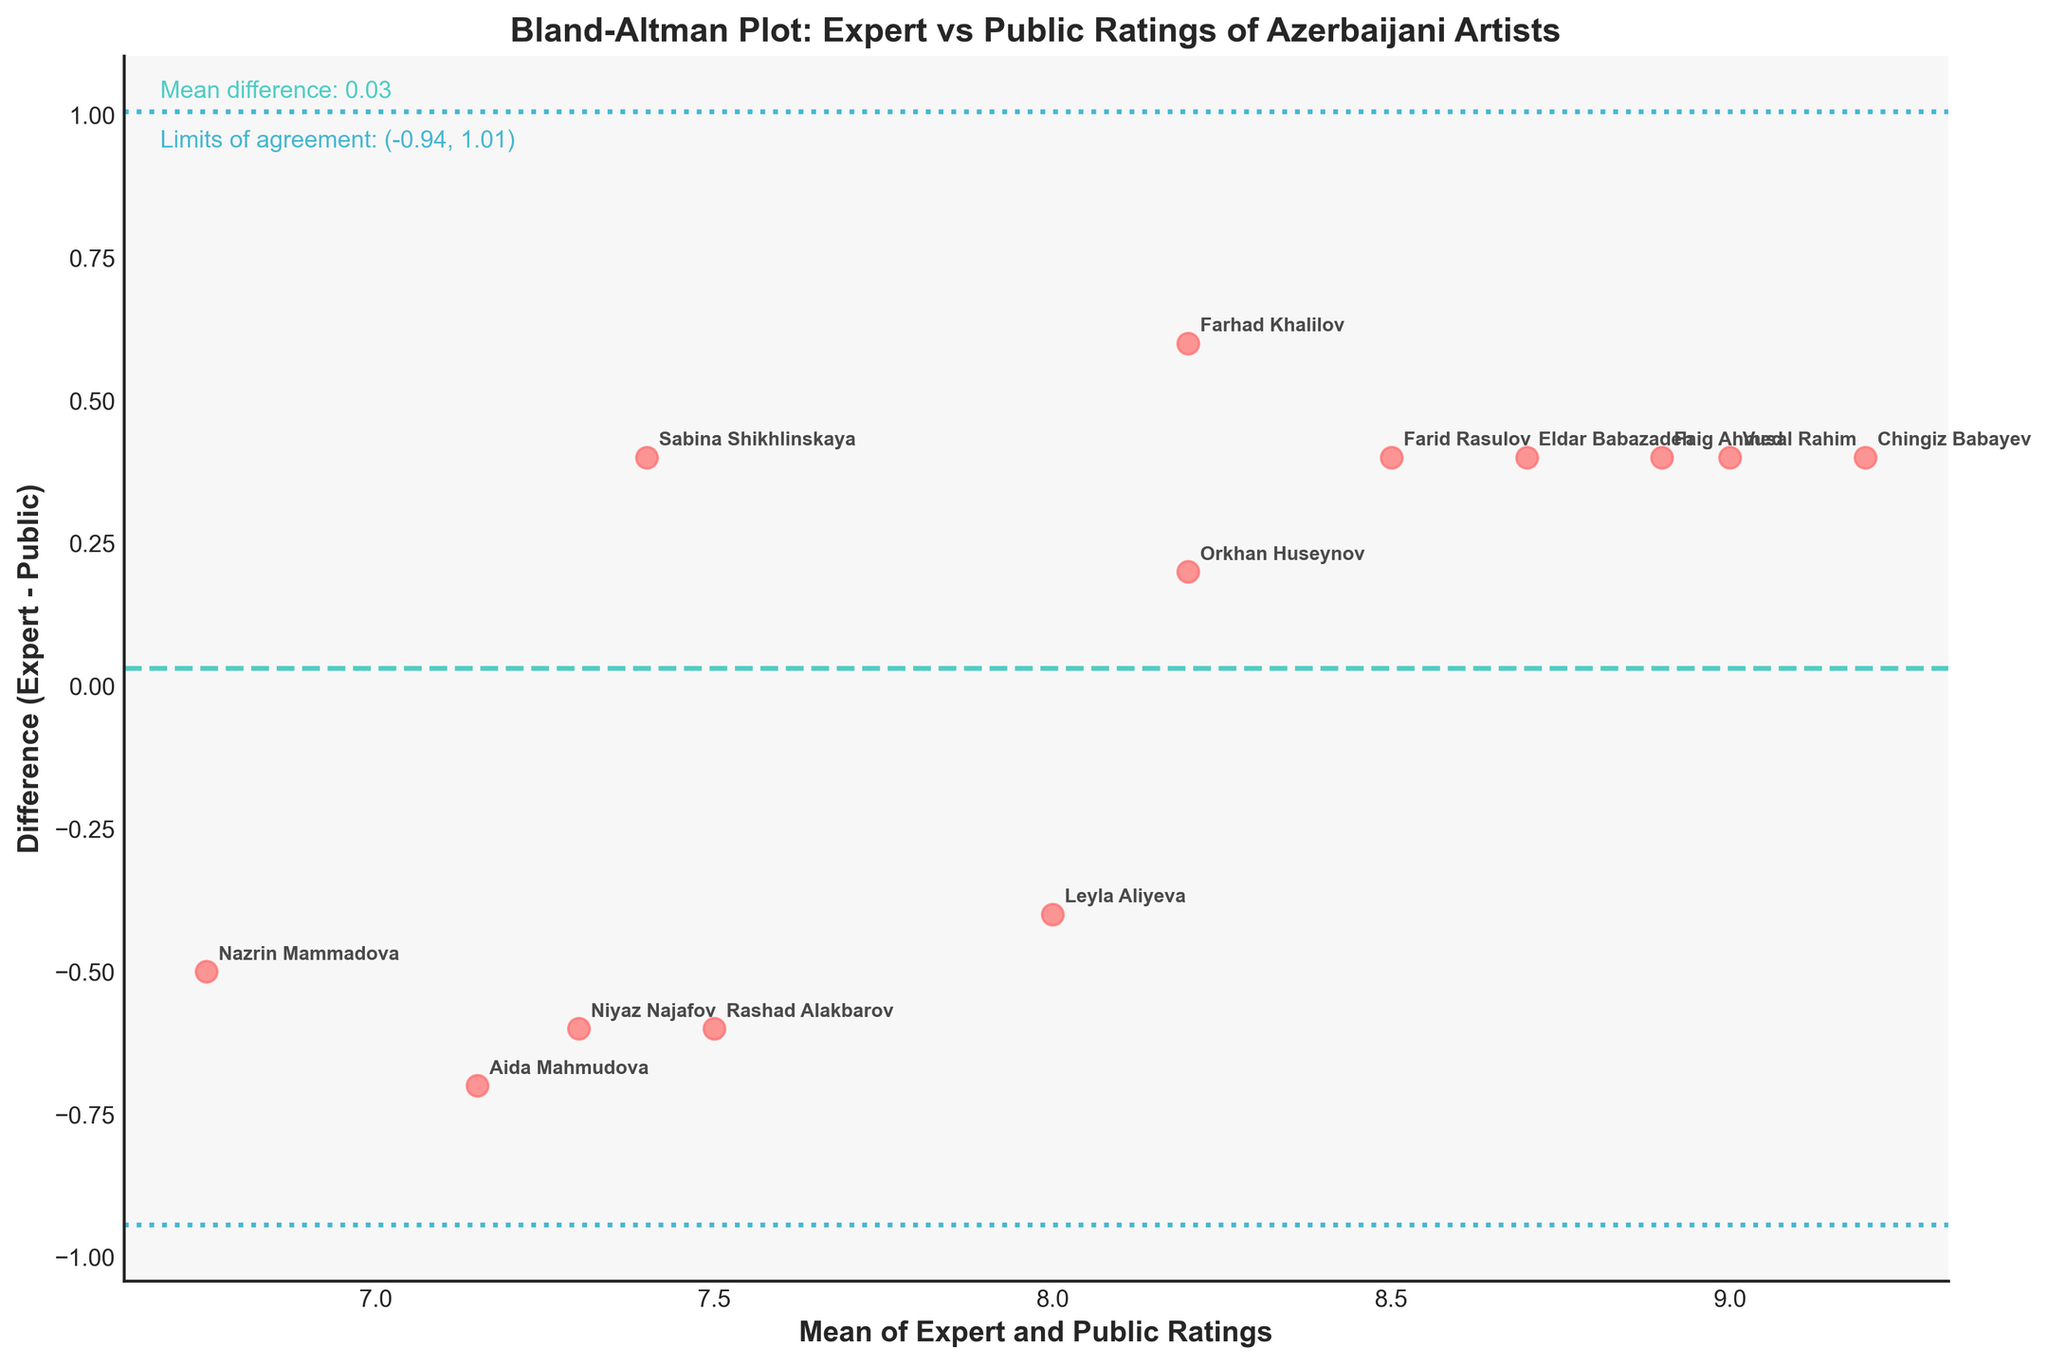What is the title of the plot? The title of the plot is usually located at the top of the figure and provides a brief description of what the plot represents. In this case, the title clearly states that the plot is a Bland-Altman plot comparing expert and public ratings of Azerbaijani artists.
Answer: Bland-Altman Plot: Expert vs Public Ratings of Azerbaijani Artists How many artists' data points are there in the plot? Each artist represents a data point on the Bland-Altman plot, as we have the ratings for 13 artists, hence there are 13 data points.
Answer: 13 What color represents the data points in the plot? The data points on the graph are clearly marked by a specific color in the figure.
Answer: Red What line indicates the mean difference between expert and public ratings? The mean difference is represented by a dashed line in the plot, clearly distinguishable by its color and line style.
Answer: The teal dashed line What are the limits of agreement in the plot? The limits of agreement are shown by two dotted lines in the plot, with a corresponding label stating these values clearly.
Answer: (-0.83, 1.51) Whose rating among the artists has the greatest difference between expert and public? By examining the scatter points and the y-axis, identify the maximum vertical distance from the zero difference line.
Answer: Sabina Shikhlinskaya Which artist has the closest agreement between expert and public ratings? Find the data point closest to the zero line, this indicates the smallest difference between expert and public ratings.
Answer: Orkhan Huseynov Is the difference between expert and public ratings more often positive or negative? Looking at the scatter points, observe if more points lie above or below the zero line.
Answer: Mostly positive What is the mean difference between expert and public ratings? The mean difference is a value indicated by one of the horizontal lines, which usually is displayed on the side of the plot.
Answer: 0.34 What does the spread of the data points tell us about the agreement between expert and public ratings? Analyze the dispersion of the points around the limits of agreement and the mean difference to determine how close or varied the expert and public ratings are.
Answer: The ratings largely agree, but there are some variations 